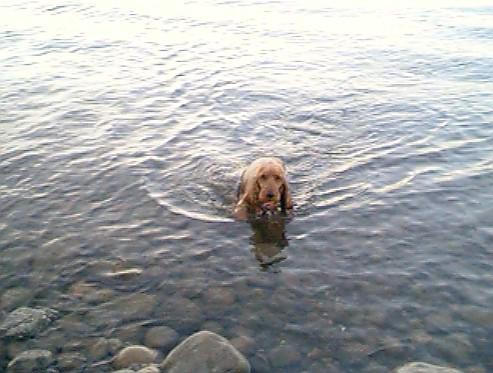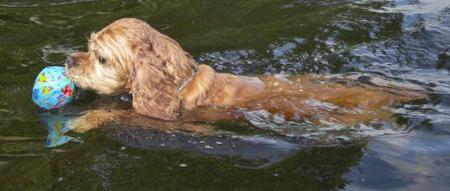The first image is the image on the left, the second image is the image on the right. Considering the images on both sides, is "One image shows at least three spaniel dogs swimming horizontally in the same direction across a swimming pool." valid? Answer yes or no. No. The first image is the image on the left, the second image is the image on the right. Assess this claim about the two images: "In one of the images there are at least three dogs swimming". Correct or not? Answer yes or no. No. 